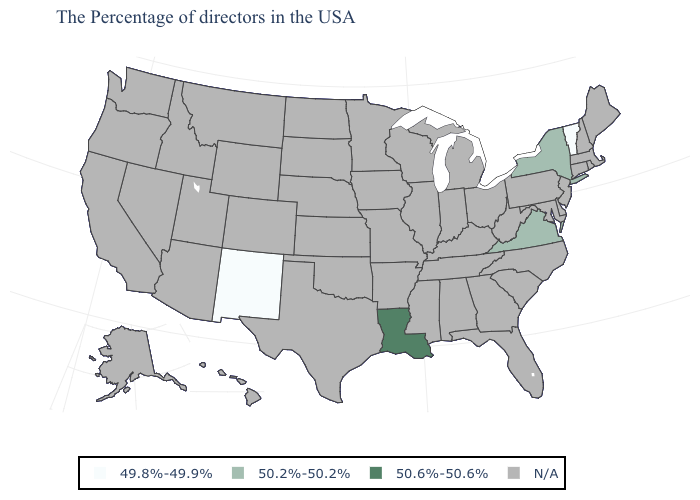Which states have the lowest value in the USA?
Concise answer only. Vermont, New Mexico. Which states have the lowest value in the West?
Short answer required. New Mexico. What is the highest value in the South ?
Write a very short answer. 50.6%-50.6%. What is the value of Alabama?
Concise answer only. N/A. Which states have the lowest value in the Northeast?
Be succinct. Vermont. Name the states that have a value in the range 50.2%-50.2%?
Give a very brief answer. New York, Virginia. Name the states that have a value in the range 49.8%-49.9%?
Concise answer only. Vermont, New Mexico. Which states have the lowest value in the USA?
Quick response, please. Vermont, New Mexico. What is the value of South Carolina?
Keep it brief. N/A. What is the lowest value in the South?
Short answer required. 50.2%-50.2%. Name the states that have a value in the range N/A?
Concise answer only. Maine, Massachusetts, Rhode Island, New Hampshire, Connecticut, New Jersey, Delaware, Maryland, Pennsylvania, North Carolina, South Carolina, West Virginia, Ohio, Florida, Georgia, Michigan, Kentucky, Indiana, Alabama, Tennessee, Wisconsin, Illinois, Mississippi, Missouri, Arkansas, Minnesota, Iowa, Kansas, Nebraska, Oklahoma, Texas, South Dakota, North Dakota, Wyoming, Colorado, Utah, Montana, Arizona, Idaho, Nevada, California, Washington, Oregon, Alaska, Hawaii. 